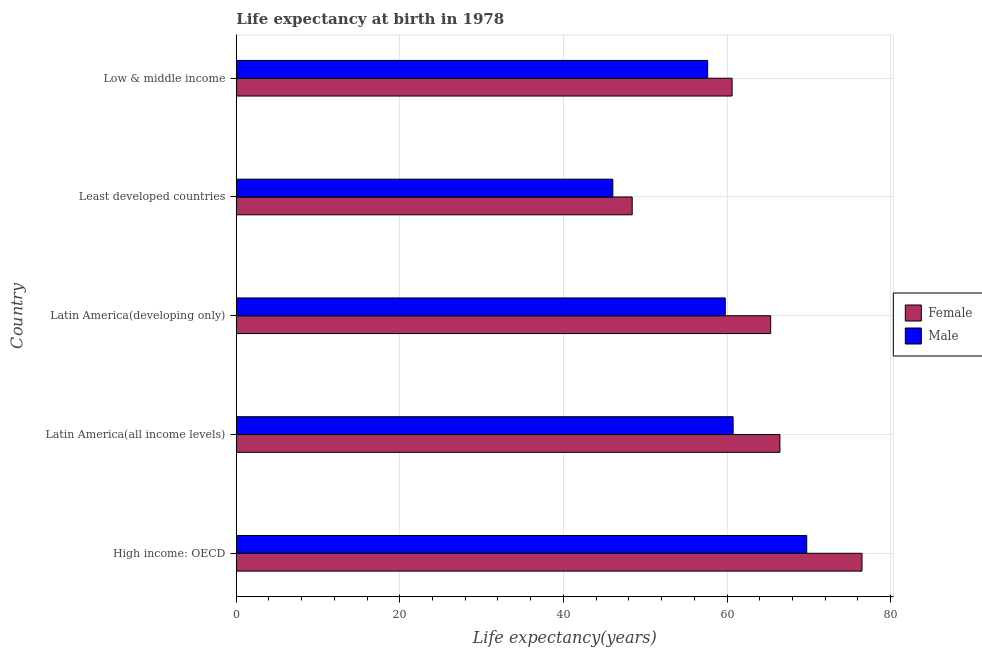How many different coloured bars are there?
Make the answer very short. 2. How many groups of bars are there?
Your answer should be compact. 5. How many bars are there on the 2nd tick from the top?
Provide a short and direct response. 2. What is the label of the 4th group of bars from the top?
Keep it short and to the point. Latin America(all income levels). What is the life expectancy(male) in Latin America(developing only)?
Your response must be concise. 59.79. Across all countries, what is the maximum life expectancy(female)?
Your answer should be very brief. 76.51. Across all countries, what is the minimum life expectancy(female)?
Your response must be concise. 48.41. In which country was the life expectancy(female) maximum?
Ensure brevity in your answer.  High income: OECD. In which country was the life expectancy(female) minimum?
Provide a succinct answer. Least developed countries. What is the total life expectancy(female) in the graph?
Provide a succinct answer. 317.35. What is the difference between the life expectancy(female) in High income: OECD and that in Low & middle income?
Offer a terse response. 15.88. What is the difference between the life expectancy(female) in Latin America(developing only) and the life expectancy(male) in Latin America(all income levels)?
Give a very brief answer. 4.59. What is the average life expectancy(male) per country?
Your answer should be compact. 58.79. What is the difference between the life expectancy(male) and life expectancy(female) in Least developed countries?
Offer a terse response. -2.37. In how many countries, is the life expectancy(female) greater than 4 years?
Your response must be concise. 5. What is the ratio of the life expectancy(female) in High income: OECD to that in Low & middle income?
Provide a succinct answer. 1.26. Is the life expectancy(male) in Latin America(all income levels) less than that in Low & middle income?
Make the answer very short. No. What is the difference between the highest and the lowest life expectancy(male)?
Make the answer very short. 23.71. In how many countries, is the life expectancy(female) greater than the average life expectancy(female) taken over all countries?
Provide a succinct answer. 3. Is the sum of the life expectancy(female) in Latin America(all income levels) and Least developed countries greater than the maximum life expectancy(male) across all countries?
Offer a terse response. Yes. What does the 2nd bar from the bottom in Least developed countries represents?
Ensure brevity in your answer.  Male. How many bars are there?
Your response must be concise. 10. Are all the bars in the graph horizontal?
Provide a succinct answer. Yes. What is the difference between two consecutive major ticks on the X-axis?
Your answer should be very brief. 20. Are the values on the major ticks of X-axis written in scientific E-notation?
Your answer should be very brief. No. Does the graph contain grids?
Your answer should be very brief. Yes. Where does the legend appear in the graph?
Offer a terse response. Center right. How are the legend labels stacked?
Your answer should be very brief. Vertical. What is the title of the graph?
Ensure brevity in your answer.  Life expectancy at birth in 1978. What is the label or title of the X-axis?
Provide a short and direct response. Life expectancy(years). What is the Life expectancy(years) of Female in High income: OECD?
Your answer should be very brief. 76.51. What is the Life expectancy(years) of Male in High income: OECD?
Ensure brevity in your answer.  69.75. What is the Life expectancy(years) in Female in Latin America(all income levels)?
Provide a succinct answer. 66.47. What is the Life expectancy(years) of Male in Latin America(all income levels)?
Keep it short and to the point. 60.75. What is the Life expectancy(years) of Female in Latin America(developing only)?
Your answer should be compact. 65.34. What is the Life expectancy(years) in Male in Latin America(developing only)?
Your answer should be very brief. 59.79. What is the Life expectancy(years) in Female in Least developed countries?
Your answer should be very brief. 48.41. What is the Life expectancy(years) in Male in Least developed countries?
Your response must be concise. 46.04. What is the Life expectancy(years) in Female in Low & middle income?
Offer a terse response. 60.62. What is the Life expectancy(years) in Male in Low & middle income?
Offer a very short reply. 57.64. Across all countries, what is the maximum Life expectancy(years) of Female?
Give a very brief answer. 76.51. Across all countries, what is the maximum Life expectancy(years) in Male?
Give a very brief answer. 69.75. Across all countries, what is the minimum Life expectancy(years) of Female?
Your answer should be very brief. 48.41. Across all countries, what is the minimum Life expectancy(years) in Male?
Offer a terse response. 46.04. What is the total Life expectancy(years) in Female in the graph?
Ensure brevity in your answer.  317.35. What is the total Life expectancy(years) in Male in the graph?
Give a very brief answer. 293.96. What is the difference between the Life expectancy(years) in Female in High income: OECD and that in Latin America(all income levels)?
Provide a short and direct response. 10.04. What is the difference between the Life expectancy(years) in Male in High income: OECD and that in Latin America(all income levels)?
Your answer should be compact. 9. What is the difference between the Life expectancy(years) of Female in High income: OECD and that in Latin America(developing only)?
Your answer should be compact. 11.17. What is the difference between the Life expectancy(years) of Male in High income: OECD and that in Latin America(developing only)?
Your answer should be compact. 9.96. What is the difference between the Life expectancy(years) in Female in High income: OECD and that in Least developed countries?
Make the answer very short. 28.1. What is the difference between the Life expectancy(years) of Male in High income: OECD and that in Least developed countries?
Offer a terse response. 23.71. What is the difference between the Life expectancy(years) in Female in High income: OECD and that in Low & middle income?
Your answer should be very brief. 15.88. What is the difference between the Life expectancy(years) of Male in High income: OECD and that in Low & middle income?
Provide a short and direct response. 12.11. What is the difference between the Life expectancy(years) in Female in Latin America(all income levels) and that in Latin America(developing only)?
Provide a short and direct response. 1.13. What is the difference between the Life expectancy(years) of Male in Latin America(all income levels) and that in Latin America(developing only)?
Your response must be concise. 0.96. What is the difference between the Life expectancy(years) in Female in Latin America(all income levels) and that in Least developed countries?
Offer a very short reply. 18.06. What is the difference between the Life expectancy(years) in Male in Latin America(all income levels) and that in Least developed countries?
Offer a terse response. 14.71. What is the difference between the Life expectancy(years) in Female in Latin America(all income levels) and that in Low & middle income?
Offer a very short reply. 5.85. What is the difference between the Life expectancy(years) in Male in Latin America(all income levels) and that in Low & middle income?
Your answer should be compact. 3.11. What is the difference between the Life expectancy(years) in Female in Latin America(developing only) and that in Least developed countries?
Provide a succinct answer. 16.93. What is the difference between the Life expectancy(years) in Male in Latin America(developing only) and that in Least developed countries?
Offer a very short reply. 13.75. What is the difference between the Life expectancy(years) of Female in Latin America(developing only) and that in Low & middle income?
Your response must be concise. 4.72. What is the difference between the Life expectancy(years) of Male in Latin America(developing only) and that in Low & middle income?
Your answer should be compact. 2.15. What is the difference between the Life expectancy(years) in Female in Least developed countries and that in Low & middle income?
Offer a terse response. -12.21. What is the difference between the Life expectancy(years) of Male in Least developed countries and that in Low & middle income?
Offer a very short reply. -11.6. What is the difference between the Life expectancy(years) in Female in High income: OECD and the Life expectancy(years) in Male in Latin America(all income levels)?
Give a very brief answer. 15.76. What is the difference between the Life expectancy(years) in Female in High income: OECD and the Life expectancy(years) in Male in Latin America(developing only)?
Give a very brief answer. 16.72. What is the difference between the Life expectancy(years) of Female in High income: OECD and the Life expectancy(years) of Male in Least developed countries?
Keep it short and to the point. 30.47. What is the difference between the Life expectancy(years) in Female in High income: OECD and the Life expectancy(years) in Male in Low & middle income?
Provide a short and direct response. 18.87. What is the difference between the Life expectancy(years) in Female in Latin America(all income levels) and the Life expectancy(years) in Male in Latin America(developing only)?
Offer a terse response. 6.68. What is the difference between the Life expectancy(years) of Female in Latin America(all income levels) and the Life expectancy(years) of Male in Least developed countries?
Keep it short and to the point. 20.43. What is the difference between the Life expectancy(years) of Female in Latin America(all income levels) and the Life expectancy(years) of Male in Low & middle income?
Make the answer very short. 8.83. What is the difference between the Life expectancy(years) in Female in Latin America(developing only) and the Life expectancy(years) in Male in Least developed countries?
Your answer should be compact. 19.3. What is the difference between the Life expectancy(years) in Female in Latin America(developing only) and the Life expectancy(years) in Male in Low & middle income?
Offer a terse response. 7.71. What is the difference between the Life expectancy(years) in Female in Least developed countries and the Life expectancy(years) in Male in Low & middle income?
Make the answer very short. -9.23. What is the average Life expectancy(years) of Female per country?
Ensure brevity in your answer.  63.47. What is the average Life expectancy(years) of Male per country?
Ensure brevity in your answer.  58.79. What is the difference between the Life expectancy(years) of Female and Life expectancy(years) of Male in High income: OECD?
Offer a terse response. 6.76. What is the difference between the Life expectancy(years) of Female and Life expectancy(years) of Male in Latin America(all income levels)?
Give a very brief answer. 5.72. What is the difference between the Life expectancy(years) of Female and Life expectancy(years) of Male in Latin America(developing only)?
Ensure brevity in your answer.  5.55. What is the difference between the Life expectancy(years) of Female and Life expectancy(years) of Male in Least developed countries?
Offer a terse response. 2.37. What is the difference between the Life expectancy(years) of Female and Life expectancy(years) of Male in Low & middle income?
Provide a succinct answer. 2.99. What is the ratio of the Life expectancy(years) in Female in High income: OECD to that in Latin America(all income levels)?
Provide a short and direct response. 1.15. What is the ratio of the Life expectancy(years) of Male in High income: OECD to that in Latin America(all income levels)?
Keep it short and to the point. 1.15. What is the ratio of the Life expectancy(years) in Female in High income: OECD to that in Latin America(developing only)?
Make the answer very short. 1.17. What is the ratio of the Life expectancy(years) of Male in High income: OECD to that in Latin America(developing only)?
Give a very brief answer. 1.17. What is the ratio of the Life expectancy(years) in Female in High income: OECD to that in Least developed countries?
Give a very brief answer. 1.58. What is the ratio of the Life expectancy(years) in Male in High income: OECD to that in Least developed countries?
Offer a terse response. 1.51. What is the ratio of the Life expectancy(years) of Female in High income: OECD to that in Low & middle income?
Your answer should be compact. 1.26. What is the ratio of the Life expectancy(years) in Male in High income: OECD to that in Low & middle income?
Offer a terse response. 1.21. What is the ratio of the Life expectancy(years) of Female in Latin America(all income levels) to that in Latin America(developing only)?
Your answer should be compact. 1.02. What is the ratio of the Life expectancy(years) in Male in Latin America(all income levels) to that in Latin America(developing only)?
Provide a short and direct response. 1.02. What is the ratio of the Life expectancy(years) of Female in Latin America(all income levels) to that in Least developed countries?
Keep it short and to the point. 1.37. What is the ratio of the Life expectancy(years) of Male in Latin America(all income levels) to that in Least developed countries?
Your answer should be compact. 1.32. What is the ratio of the Life expectancy(years) of Female in Latin America(all income levels) to that in Low & middle income?
Keep it short and to the point. 1.1. What is the ratio of the Life expectancy(years) of Male in Latin America(all income levels) to that in Low & middle income?
Offer a terse response. 1.05. What is the ratio of the Life expectancy(years) of Female in Latin America(developing only) to that in Least developed countries?
Offer a very short reply. 1.35. What is the ratio of the Life expectancy(years) of Male in Latin America(developing only) to that in Least developed countries?
Offer a terse response. 1.3. What is the ratio of the Life expectancy(years) of Female in Latin America(developing only) to that in Low & middle income?
Make the answer very short. 1.08. What is the ratio of the Life expectancy(years) in Male in Latin America(developing only) to that in Low & middle income?
Offer a terse response. 1.04. What is the ratio of the Life expectancy(years) in Female in Least developed countries to that in Low & middle income?
Your response must be concise. 0.8. What is the ratio of the Life expectancy(years) of Male in Least developed countries to that in Low & middle income?
Offer a terse response. 0.8. What is the difference between the highest and the second highest Life expectancy(years) of Female?
Your response must be concise. 10.04. What is the difference between the highest and the second highest Life expectancy(years) of Male?
Keep it short and to the point. 9. What is the difference between the highest and the lowest Life expectancy(years) of Female?
Make the answer very short. 28.1. What is the difference between the highest and the lowest Life expectancy(years) in Male?
Your response must be concise. 23.71. 